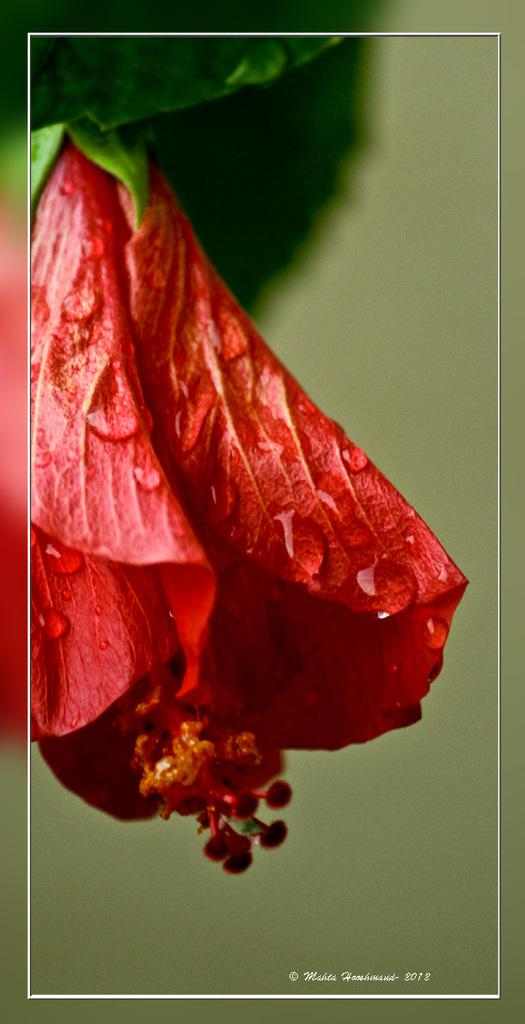What type of flower is present in the image? There is a red color flower in the image. What other plant element can be seen in the image? There is a green color leaf in the image. Can you tell me how the deer is interacting with the flower in the image? There is no deer present in the image; it only features a red flower and a green leaf. Is the bike parked next to the flower in the image? There is no bike present in the image; it only features a red flower and a green leaf. 